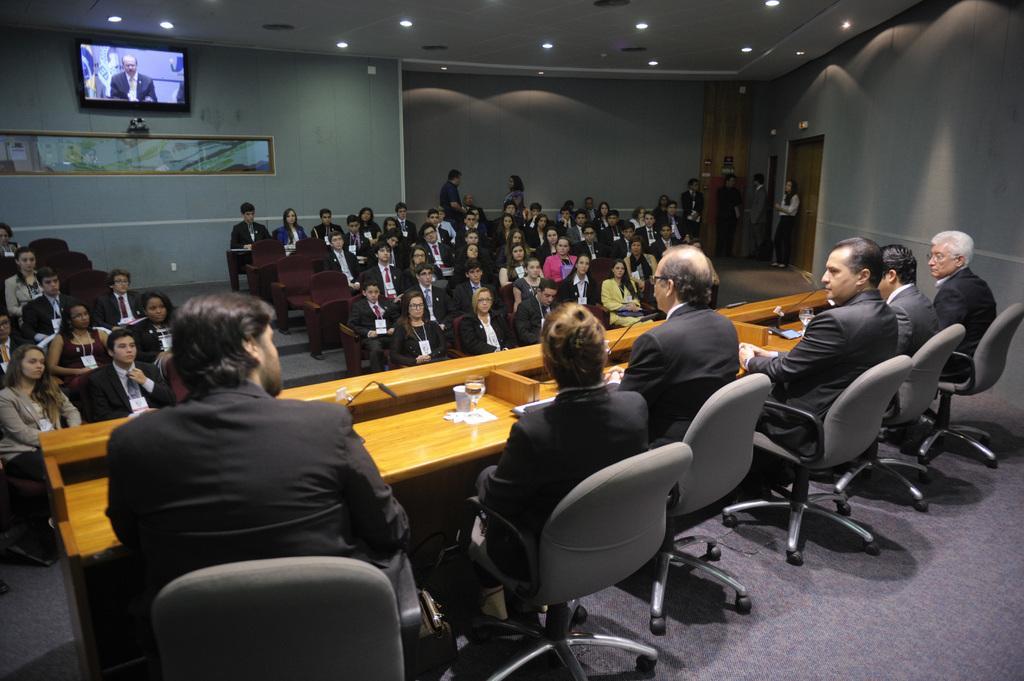How would you summarize this image in a sentence or two? In this image I can see few people are sitting on the chairs and these people are wearing the blazers. They are sitting in front of the table. On the table there is a glass ,papers and the mic. In front of them there are group of people sitting and few are standing. In the back there is a screen and frame to the wall. In the top there are lights. 